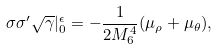<formula> <loc_0><loc_0><loc_500><loc_500>\sigma \sigma ^ { \prime } \sqrt { \gamma } | _ { 0 } ^ { \epsilon } = - \frac { 1 } { 2 M _ { 6 } ^ { 4 } } ( \mu _ { \rho } + \mu _ { \theta } ) ,</formula> 